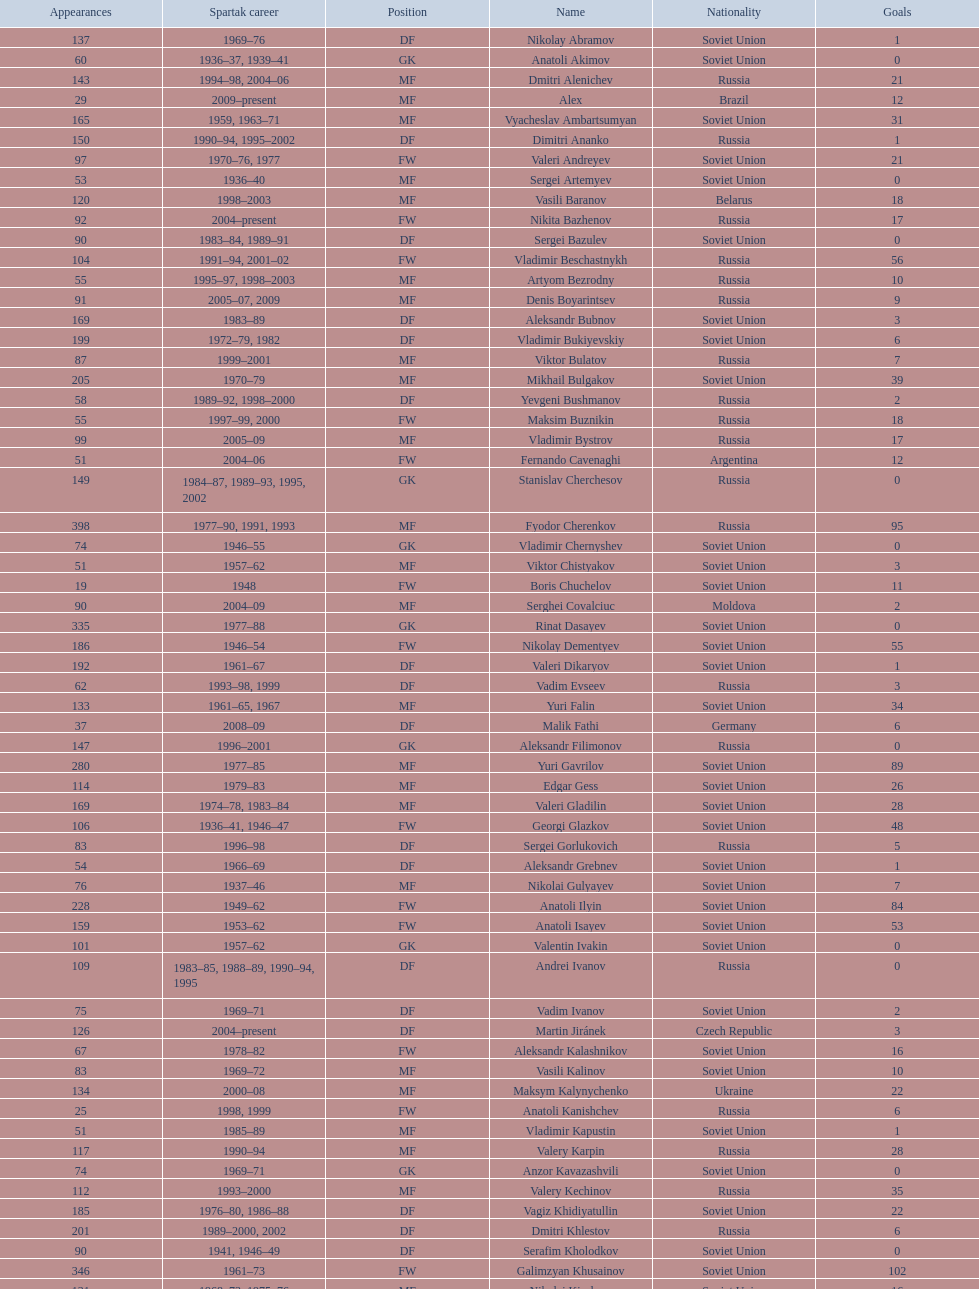Who had the highest number of appearances? Fyodor Cherenkov. 